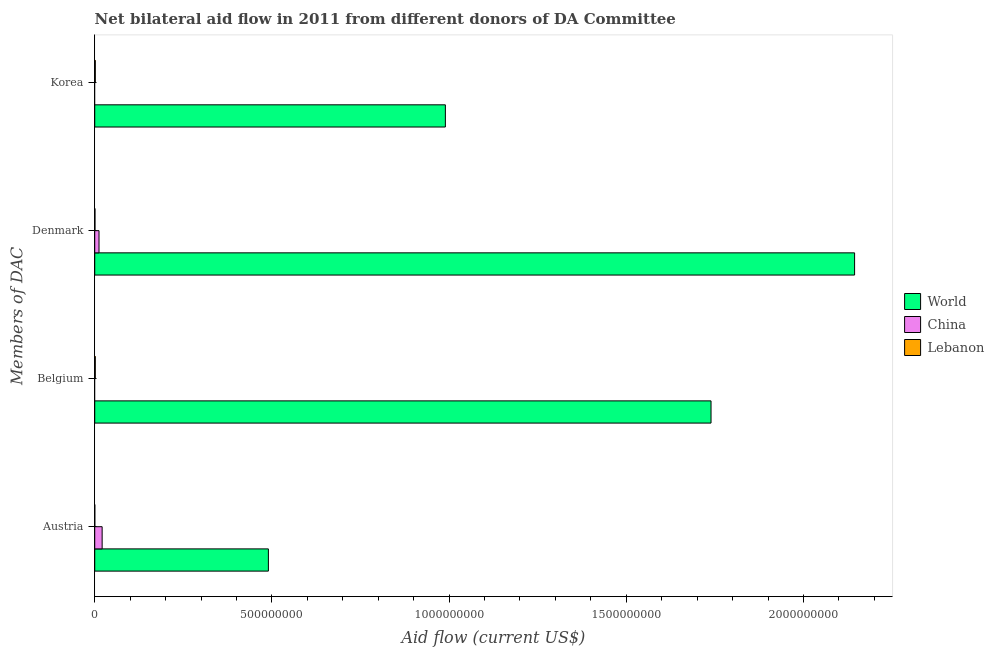Are the number of bars per tick equal to the number of legend labels?
Offer a terse response. No. How many bars are there on the 2nd tick from the bottom?
Provide a short and direct response. 2. What is the amount of aid given by belgium in China?
Provide a succinct answer. 0. Across all countries, what is the maximum amount of aid given by korea?
Give a very brief answer. 9.90e+08. Across all countries, what is the minimum amount of aid given by austria?
Your answer should be very brief. 1.70e+05. In which country was the amount of aid given by korea maximum?
Your answer should be very brief. World. What is the total amount of aid given by denmark in the graph?
Provide a short and direct response. 2.16e+09. What is the difference between the amount of aid given by austria in World and that in Lebanon?
Your response must be concise. 4.90e+08. What is the difference between the amount of aid given by austria in World and the amount of aid given by belgium in Lebanon?
Give a very brief answer. 4.89e+08. What is the average amount of aid given by denmark per country?
Make the answer very short. 7.19e+08. What is the difference between the amount of aid given by denmark and amount of aid given by austria in China?
Your response must be concise. -8.83e+06. What is the ratio of the amount of aid given by korea in Lebanon to that in World?
Provide a succinct answer. 0. Is the amount of aid given by austria in Lebanon less than that in World?
Provide a short and direct response. Yes. Is the difference between the amount of aid given by denmark in Lebanon and World greater than the difference between the amount of aid given by belgium in Lebanon and World?
Give a very brief answer. No. What is the difference between the highest and the second highest amount of aid given by denmark?
Ensure brevity in your answer.  2.13e+09. What is the difference between the highest and the lowest amount of aid given by austria?
Ensure brevity in your answer.  4.90e+08. In how many countries, is the amount of aid given by belgium greater than the average amount of aid given by belgium taken over all countries?
Offer a very short reply. 1. Is it the case that in every country, the sum of the amount of aid given by austria and amount of aid given by belgium is greater than the amount of aid given by denmark?
Offer a very short reply. Yes. How many countries are there in the graph?
Make the answer very short. 3. What is the difference between two consecutive major ticks on the X-axis?
Your answer should be compact. 5.00e+08. Are the values on the major ticks of X-axis written in scientific E-notation?
Ensure brevity in your answer.  No. Does the graph contain any zero values?
Offer a terse response. Yes. Where does the legend appear in the graph?
Offer a very short reply. Center right. How are the legend labels stacked?
Your response must be concise. Vertical. What is the title of the graph?
Offer a very short reply. Net bilateral aid flow in 2011 from different donors of DA Committee. Does "Kenya" appear as one of the legend labels in the graph?
Provide a succinct answer. No. What is the label or title of the X-axis?
Ensure brevity in your answer.  Aid flow (current US$). What is the label or title of the Y-axis?
Ensure brevity in your answer.  Members of DAC. What is the Aid flow (current US$) in World in Austria?
Keep it short and to the point. 4.90e+08. What is the Aid flow (current US$) in China in Austria?
Give a very brief answer. 2.09e+07. What is the Aid flow (current US$) of Lebanon in Austria?
Make the answer very short. 1.70e+05. What is the Aid flow (current US$) in World in Belgium?
Give a very brief answer. 1.74e+09. What is the Aid flow (current US$) in Lebanon in Belgium?
Your answer should be compact. 1.57e+06. What is the Aid flow (current US$) of World in Denmark?
Ensure brevity in your answer.  2.14e+09. What is the Aid flow (current US$) in China in Denmark?
Offer a terse response. 1.21e+07. What is the Aid flow (current US$) of Lebanon in Denmark?
Give a very brief answer. 6.90e+05. What is the Aid flow (current US$) in World in Korea?
Your answer should be very brief. 9.90e+08. What is the Aid flow (current US$) of China in Korea?
Provide a short and direct response. 0. What is the Aid flow (current US$) of Lebanon in Korea?
Your answer should be very brief. 1.58e+06. Across all Members of DAC, what is the maximum Aid flow (current US$) in World?
Provide a short and direct response. 2.14e+09. Across all Members of DAC, what is the maximum Aid flow (current US$) of China?
Give a very brief answer. 2.09e+07. Across all Members of DAC, what is the maximum Aid flow (current US$) in Lebanon?
Offer a terse response. 1.58e+06. Across all Members of DAC, what is the minimum Aid flow (current US$) of World?
Give a very brief answer. 4.90e+08. What is the total Aid flow (current US$) in World in the graph?
Provide a short and direct response. 5.36e+09. What is the total Aid flow (current US$) of China in the graph?
Offer a very short reply. 3.30e+07. What is the total Aid flow (current US$) of Lebanon in the graph?
Keep it short and to the point. 4.01e+06. What is the difference between the Aid flow (current US$) in World in Austria and that in Belgium?
Give a very brief answer. -1.25e+09. What is the difference between the Aid flow (current US$) in Lebanon in Austria and that in Belgium?
Give a very brief answer. -1.40e+06. What is the difference between the Aid flow (current US$) of World in Austria and that in Denmark?
Your answer should be very brief. -1.65e+09. What is the difference between the Aid flow (current US$) in China in Austria and that in Denmark?
Make the answer very short. 8.83e+06. What is the difference between the Aid flow (current US$) in Lebanon in Austria and that in Denmark?
Your answer should be compact. -5.20e+05. What is the difference between the Aid flow (current US$) of World in Austria and that in Korea?
Offer a very short reply. -4.99e+08. What is the difference between the Aid flow (current US$) of Lebanon in Austria and that in Korea?
Keep it short and to the point. -1.41e+06. What is the difference between the Aid flow (current US$) of World in Belgium and that in Denmark?
Provide a short and direct response. -4.05e+08. What is the difference between the Aid flow (current US$) of Lebanon in Belgium and that in Denmark?
Keep it short and to the point. 8.80e+05. What is the difference between the Aid flow (current US$) in World in Belgium and that in Korea?
Keep it short and to the point. 7.50e+08. What is the difference between the Aid flow (current US$) in Lebanon in Belgium and that in Korea?
Your answer should be very brief. -10000. What is the difference between the Aid flow (current US$) in World in Denmark and that in Korea?
Make the answer very short. 1.15e+09. What is the difference between the Aid flow (current US$) of Lebanon in Denmark and that in Korea?
Your response must be concise. -8.90e+05. What is the difference between the Aid flow (current US$) of World in Austria and the Aid flow (current US$) of Lebanon in Belgium?
Give a very brief answer. 4.89e+08. What is the difference between the Aid flow (current US$) of China in Austria and the Aid flow (current US$) of Lebanon in Belgium?
Give a very brief answer. 1.93e+07. What is the difference between the Aid flow (current US$) in World in Austria and the Aid flow (current US$) in China in Denmark?
Make the answer very short. 4.78e+08. What is the difference between the Aid flow (current US$) of World in Austria and the Aid flow (current US$) of Lebanon in Denmark?
Your answer should be compact. 4.89e+08. What is the difference between the Aid flow (current US$) in China in Austria and the Aid flow (current US$) in Lebanon in Denmark?
Your response must be concise. 2.02e+07. What is the difference between the Aid flow (current US$) in World in Austria and the Aid flow (current US$) in Lebanon in Korea?
Your answer should be compact. 4.88e+08. What is the difference between the Aid flow (current US$) in China in Austria and the Aid flow (current US$) in Lebanon in Korea?
Offer a terse response. 1.93e+07. What is the difference between the Aid flow (current US$) in World in Belgium and the Aid flow (current US$) in China in Denmark?
Your answer should be very brief. 1.73e+09. What is the difference between the Aid flow (current US$) in World in Belgium and the Aid flow (current US$) in Lebanon in Denmark?
Ensure brevity in your answer.  1.74e+09. What is the difference between the Aid flow (current US$) of World in Belgium and the Aid flow (current US$) of Lebanon in Korea?
Offer a terse response. 1.74e+09. What is the difference between the Aid flow (current US$) in World in Denmark and the Aid flow (current US$) in Lebanon in Korea?
Your response must be concise. 2.14e+09. What is the difference between the Aid flow (current US$) in China in Denmark and the Aid flow (current US$) in Lebanon in Korea?
Offer a terse response. 1.05e+07. What is the average Aid flow (current US$) in World per Members of DAC?
Your response must be concise. 1.34e+09. What is the average Aid flow (current US$) of China per Members of DAC?
Offer a terse response. 8.25e+06. What is the average Aid flow (current US$) of Lebanon per Members of DAC?
Provide a short and direct response. 1.00e+06. What is the difference between the Aid flow (current US$) of World and Aid flow (current US$) of China in Austria?
Provide a short and direct response. 4.69e+08. What is the difference between the Aid flow (current US$) in World and Aid flow (current US$) in Lebanon in Austria?
Your answer should be compact. 4.90e+08. What is the difference between the Aid flow (current US$) in China and Aid flow (current US$) in Lebanon in Austria?
Ensure brevity in your answer.  2.07e+07. What is the difference between the Aid flow (current US$) in World and Aid flow (current US$) in Lebanon in Belgium?
Your response must be concise. 1.74e+09. What is the difference between the Aid flow (current US$) of World and Aid flow (current US$) of China in Denmark?
Offer a terse response. 2.13e+09. What is the difference between the Aid flow (current US$) of World and Aid flow (current US$) of Lebanon in Denmark?
Give a very brief answer. 2.14e+09. What is the difference between the Aid flow (current US$) of China and Aid flow (current US$) of Lebanon in Denmark?
Offer a terse response. 1.14e+07. What is the difference between the Aid flow (current US$) in World and Aid flow (current US$) in Lebanon in Korea?
Give a very brief answer. 9.88e+08. What is the ratio of the Aid flow (current US$) in World in Austria to that in Belgium?
Give a very brief answer. 0.28. What is the ratio of the Aid flow (current US$) in Lebanon in Austria to that in Belgium?
Provide a succinct answer. 0.11. What is the ratio of the Aid flow (current US$) in World in Austria to that in Denmark?
Offer a terse response. 0.23. What is the ratio of the Aid flow (current US$) in China in Austria to that in Denmark?
Provide a succinct answer. 1.73. What is the ratio of the Aid flow (current US$) of Lebanon in Austria to that in Denmark?
Ensure brevity in your answer.  0.25. What is the ratio of the Aid flow (current US$) in World in Austria to that in Korea?
Provide a succinct answer. 0.5. What is the ratio of the Aid flow (current US$) of Lebanon in Austria to that in Korea?
Provide a succinct answer. 0.11. What is the ratio of the Aid flow (current US$) of World in Belgium to that in Denmark?
Your response must be concise. 0.81. What is the ratio of the Aid flow (current US$) in Lebanon in Belgium to that in Denmark?
Provide a short and direct response. 2.28. What is the ratio of the Aid flow (current US$) of World in Belgium to that in Korea?
Give a very brief answer. 1.76. What is the ratio of the Aid flow (current US$) in Lebanon in Belgium to that in Korea?
Your answer should be compact. 0.99. What is the ratio of the Aid flow (current US$) of World in Denmark to that in Korea?
Offer a very short reply. 2.17. What is the ratio of the Aid flow (current US$) in Lebanon in Denmark to that in Korea?
Keep it short and to the point. 0.44. What is the difference between the highest and the second highest Aid flow (current US$) of World?
Provide a succinct answer. 4.05e+08. What is the difference between the highest and the lowest Aid flow (current US$) of World?
Offer a terse response. 1.65e+09. What is the difference between the highest and the lowest Aid flow (current US$) of China?
Keep it short and to the point. 2.09e+07. What is the difference between the highest and the lowest Aid flow (current US$) in Lebanon?
Give a very brief answer. 1.41e+06. 